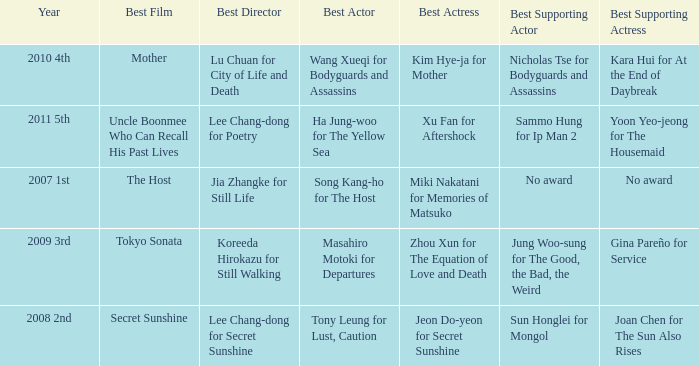Name the best supporting actress for sun honglei for mongol Joan Chen for The Sun Also Rises. 